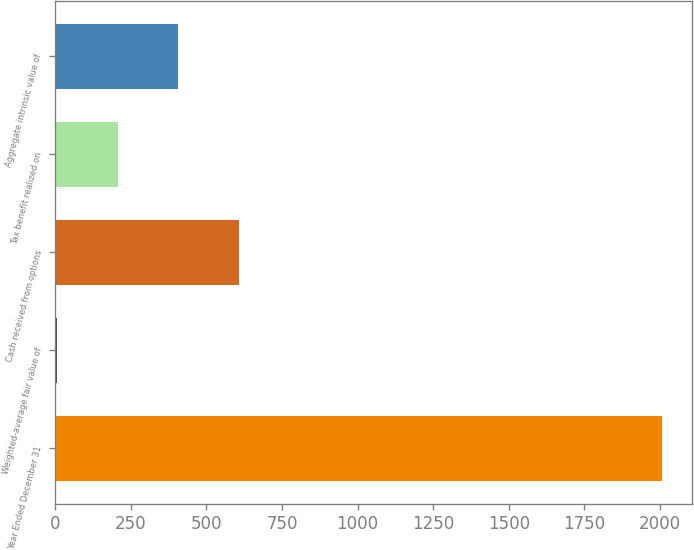Convert chart to OTSL. <chart><loc_0><loc_0><loc_500><loc_500><bar_chart><fcel>Year Ended December 31<fcel>Weighted-average fair value of<fcel>Cash received from options<fcel>Tax benefit realized on<fcel>Aggregate intrinsic value of<nl><fcel>2007<fcel>7.06<fcel>607.03<fcel>207.05<fcel>407.04<nl></chart> 